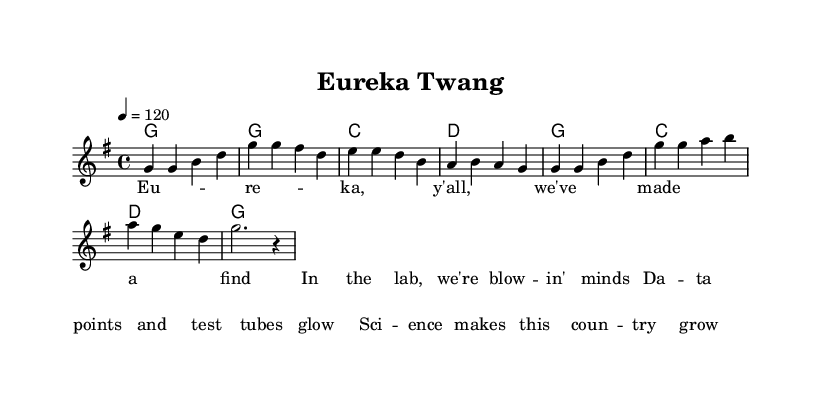What is the key signature of this music? The key signature is G major, which has one sharp (F#). This can be determined by looking at the key signature symbol present on the staff at the beginning of the piece.
Answer: G major What is the time signature of this music? The time signature is 4/4, which is indicated at the start of the sheet music. It is recognized by the notation that shows four beats per measure.
Answer: 4/4 What is the tempo marking for this music? The tempo marking is 120 beats per minute, as indicated at the beginning with the tempo indication "4 = 120". This specifies the speed at which the piece should be played.
Answer: 120 Identify the first note of the melody. The first note of the melody is G. It can be determined by examining the notes written on the staff, where the first note is positioned as a quarter note on the second line of the treble clef.
Answer: G How many measures are in the melody section? There are eight measures in the melody section, which can be counted by identifying the vertical bar lines that separate each measure in the staff. Each segment of music between two bar lines constitutes one measure.
Answer: 8 What type of musical form is predominantly used in this piece? The piece primarily follows a verse structure, which is evident from the lyrics presented and the repetitive harmonic pattern that supports the melody, characteristic of country songs.
Answer: Verse What musical elements help highlight the theme of scientific discovery in the lyrics? The lyrics mention components related to science such as "data points" and "test tubes," emphasizing the theme. These elements are combined with a celebratory and upbeat melody typical in country music, reinforcing the positive portrayal of scientific breakthroughs.
Answer: Data points, test tubes 